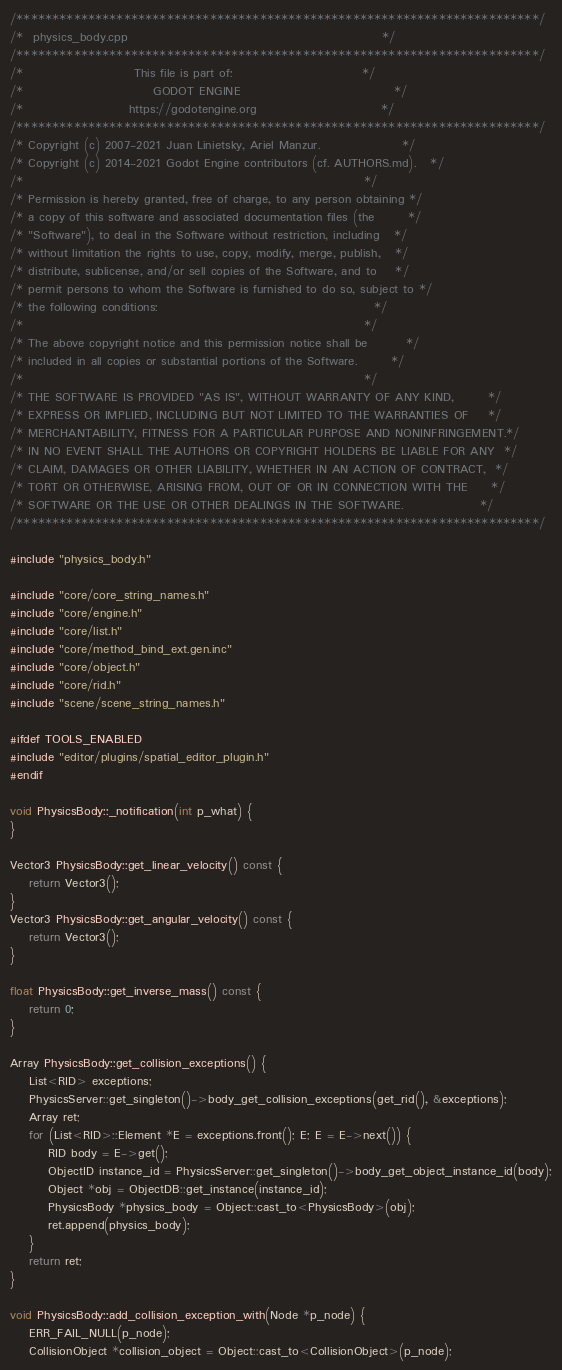Convert code to text. <code><loc_0><loc_0><loc_500><loc_500><_C++_>/*************************************************************************/
/*  physics_body.cpp                                                     */
/*************************************************************************/
/*                       This file is part of:                           */
/*                           GODOT ENGINE                                */
/*                      https://godotengine.org                          */
/*************************************************************************/
/* Copyright (c) 2007-2021 Juan Linietsky, Ariel Manzur.                 */
/* Copyright (c) 2014-2021 Godot Engine contributors (cf. AUTHORS.md).   */
/*                                                                       */
/* Permission is hereby granted, free of charge, to any person obtaining */
/* a copy of this software and associated documentation files (the       */
/* "Software"), to deal in the Software without restriction, including   */
/* without limitation the rights to use, copy, modify, merge, publish,   */
/* distribute, sublicense, and/or sell copies of the Software, and to    */
/* permit persons to whom the Software is furnished to do so, subject to */
/* the following conditions:                                             */
/*                                                                       */
/* The above copyright notice and this permission notice shall be        */
/* included in all copies or substantial portions of the Software.       */
/*                                                                       */
/* THE SOFTWARE IS PROVIDED "AS IS", WITHOUT WARRANTY OF ANY KIND,       */
/* EXPRESS OR IMPLIED, INCLUDING BUT NOT LIMITED TO THE WARRANTIES OF    */
/* MERCHANTABILITY, FITNESS FOR A PARTICULAR PURPOSE AND NONINFRINGEMENT.*/
/* IN NO EVENT SHALL THE AUTHORS OR COPYRIGHT HOLDERS BE LIABLE FOR ANY  */
/* CLAIM, DAMAGES OR OTHER LIABILITY, WHETHER IN AN ACTION OF CONTRACT,  */
/* TORT OR OTHERWISE, ARISING FROM, OUT OF OR IN CONNECTION WITH THE     */
/* SOFTWARE OR THE USE OR OTHER DEALINGS IN THE SOFTWARE.                */
/*************************************************************************/

#include "physics_body.h"

#include "core/core_string_names.h"
#include "core/engine.h"
#include "core/list.h"
#include "core/method_bind_ext.gen.inc"
#include "core/object.h"
#include "core/rid.h"
#include "scene/scene_string_names.h"

#ifdef TOOLS_ENABLED
#include "editor/plugins/spatial_editor_plugin.h"
#endif

void PhysicsBody::_notification(int p_what) {
}

Vector3 PhysicsBody::get_linear_velocity() const {
	return Vector3();
}
Vector3 PhysicsBody::get_angular_velocity() const {
	return Vector3();
}

float PhysicsBody::get_inverse_mass() const {
	return 0;
}

Array PhysicsBody::get_collision_exceptions() {
	List<RID> exceptions;
	PhysicsServer::get_singleton()->body_get_collision_exceptions(get_rid(), &exceptions);
	Array ret;
	for (List<RID>::Element *E = exceptions.front(); E; E = E->next()) {
		RID body = E->get();
		ObjectID instance_id = PhysicsServer::get_singleton()->body_get_object_instance_id(body);
		Object *obj = ObjectDB::get_instance(instance_id);
		PhysicsBody *physics_body = Object::cast_to<PhysicsBody>(obj);
		ret.append(physics_body);
	}
	return ret;
}

void PhysicsBody::add_collision_exception_with(Node *p_node) {
	ERR_FAIL_NULL(p_node);
	CollisionObject *collision_object = Object::cast_to<CollisionObject>(p_node);</code> 